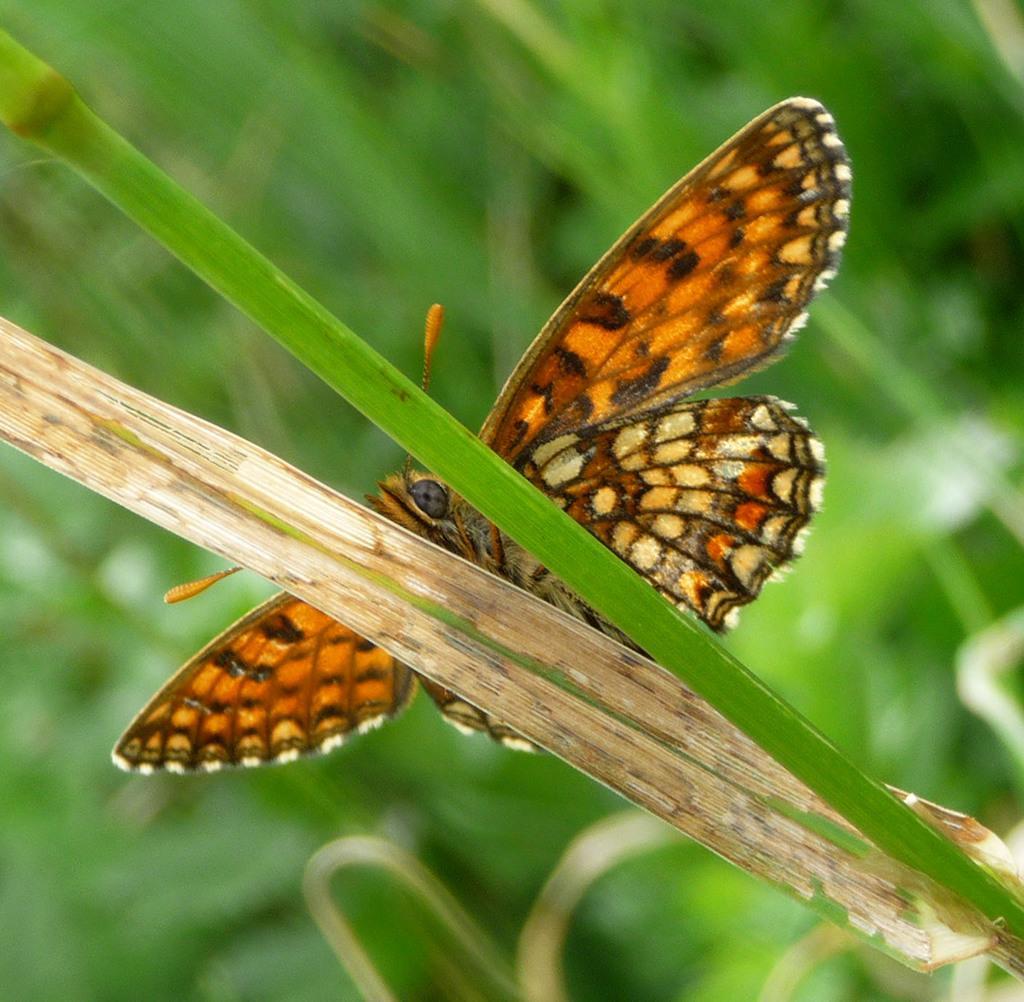Please provide a concise description of this image. In this image, we can see a butterfly sitting on the leaf and there is a blur background. 